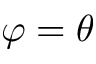Convert formula to latex. <formula><loc_0><loc_0><loc_500><loc_500>\varphi = \theta</formula> 